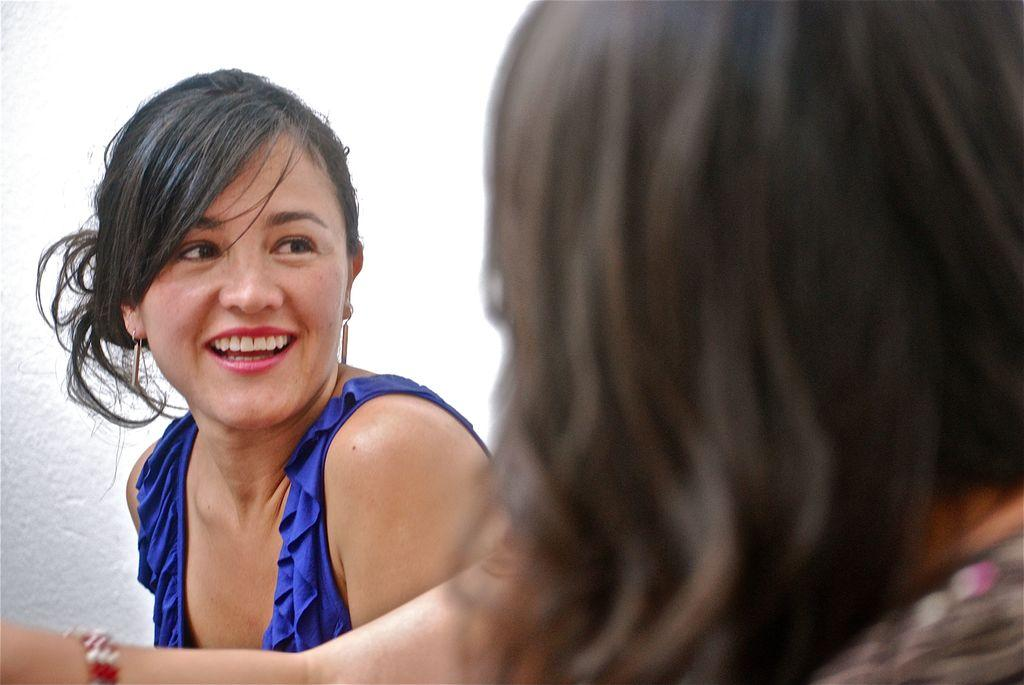How many women are in the image? There are two women in the image. What are the women doing in the image? The women are facing each other and smiling. What is the woman on the left side wearing? The woman on the left side is wearing a blue dress. What is the background of the image? There is a white wall behind the women. What type of pets can be seen playing with grain in the image? There are no pets or grain present in the image. Is there a library visible in the background of the image? No, there is no library visible in the image; it features a white wall as the background. 